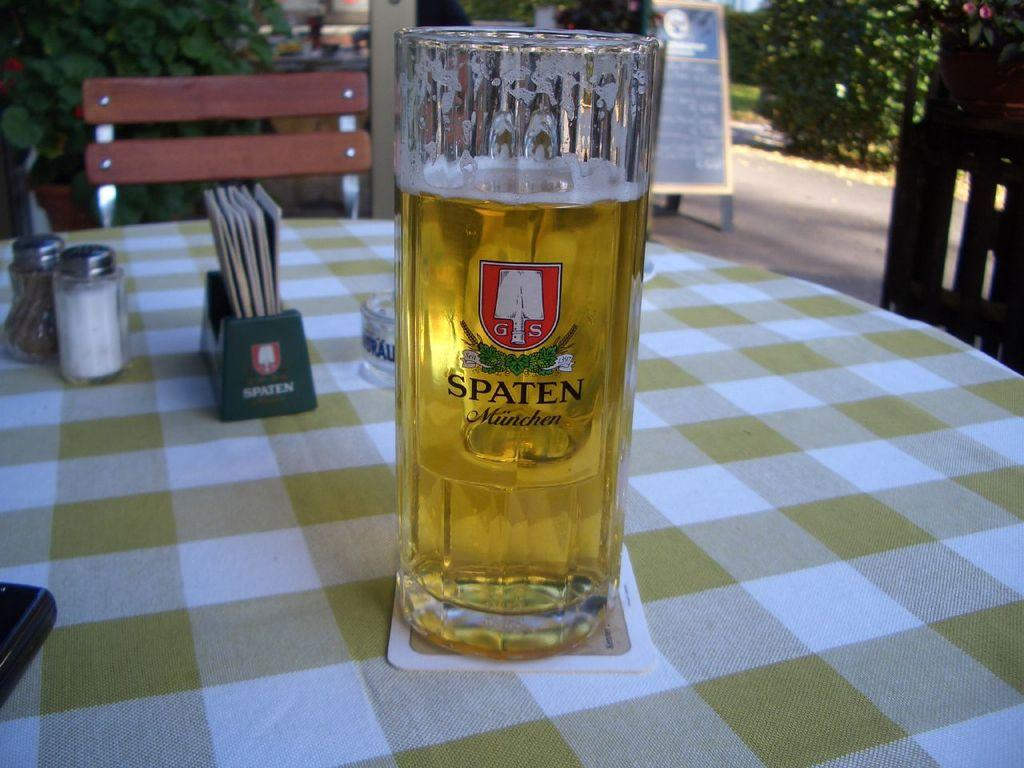<image>
Write a terse but informative summary of the picture. A pint glass of Spaten lager sits on a checkered tablecloth. 